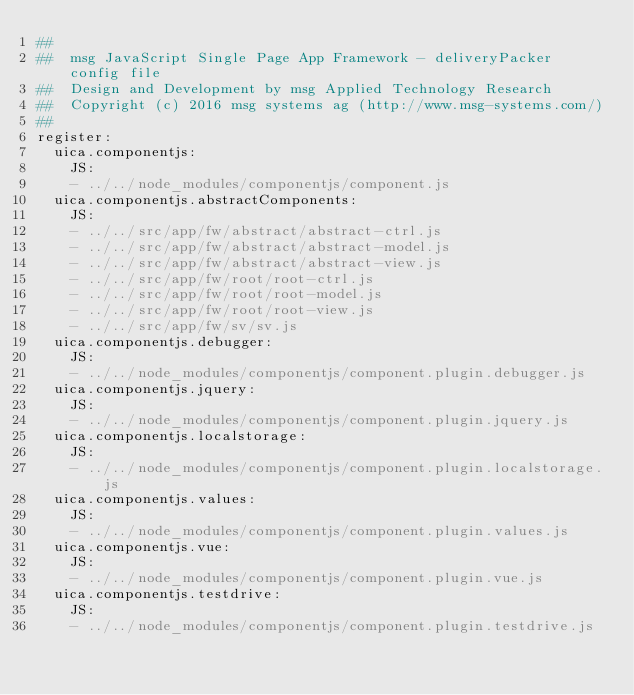<code> <loc_0><loc_0><loc_500><loc_500><_YAML_>##
##  msg JavaScript Single Page App Framework - deliveryPacker config file
##  Design and Development by msg Applied Technology Research
##  Copyright (c) 2016 msg systems ag (http://www.msg-systems.com/)
##
register:
  uica.componentjs:
    JS:
    - ../../node_modules/componentjs/component.js
  uica.componentjs.abstractComponents:
    JS:
    - ../../src/app/fw/abstract/abstract-ctrl.js
    - ../../src/app/fw/abstract/abstract-model.js
    - ../../src/app/fw/abstract/abstract-view.js
    - ../../src/app/fw/root/root-ctrl.js
    - ../../src/app/fw/root/root-model.js
    - ../../src/app/fw/root/root-view.js
    - ../../src/app/fw/sv/sv.js
  uica.componentjs.debugger:
    JS:
    - ../../node_modules/componentjs/component.plugin.debugger.js
  uica.componentjs.jquery:
    JS:
    - ../../node_modules/componentjs/component.plugin.jquery.js
  uica.componentjs.localstorage:
    JS:
    - ../../node_modules/componentjs/component.plugin.localstorage.js
  uica.componentjs.values:
    JS:
    - ../../node_modules/componentjs/component.plugin.values.js
  uica.componentjs.vue:
    JS:
    - ../../node_modules/componentjs/component.plugin.vue.js
  uica.componentjs.testdrive:
    JS:
    - ../../node_modules/componentjs/component.plugin.testdrive.js
</code> 